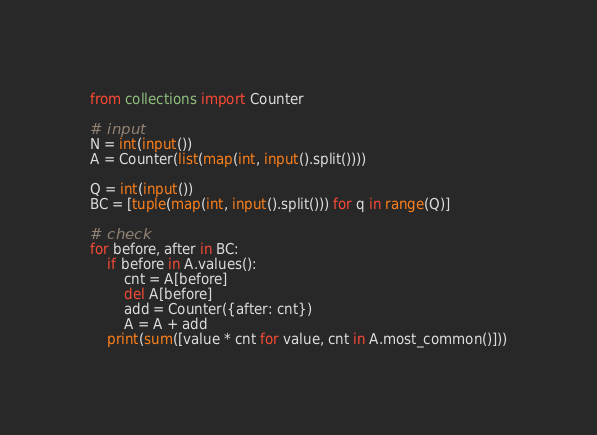<code> <loc_0><loc_0><loc_500><loc_500><_Python_>from collections import Counter

# input
N = int(input())
A = Counter(list(map(int, input().split())))

Q = int(input())
BC = [tuple(map(int, input().split())) for q in range(Q)]

# check
for before, after in BC:
    if before in A.values():
        cnt = A[before]
        del A[before]
        add = Counter({after: cnt})
        A = A + add
    print(sum([value * cnt for value, cnt in A.most_common()]))</code> 